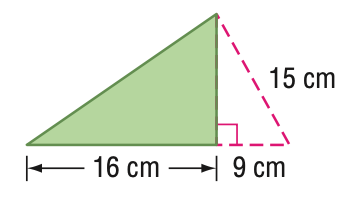Question: Find the area of the triangle. Round to the nearest tenth if necessary.
Choices:
A. 96
B. 135
C. 192
D. 240
Answer with the letter. Answer: A Question: Find the perimeter of the triangle. Round to the nearest tenth if necessary.
Choices:
A. 24
B. 48
C. 56
D. 96
Answer with the letter. Answer: B 